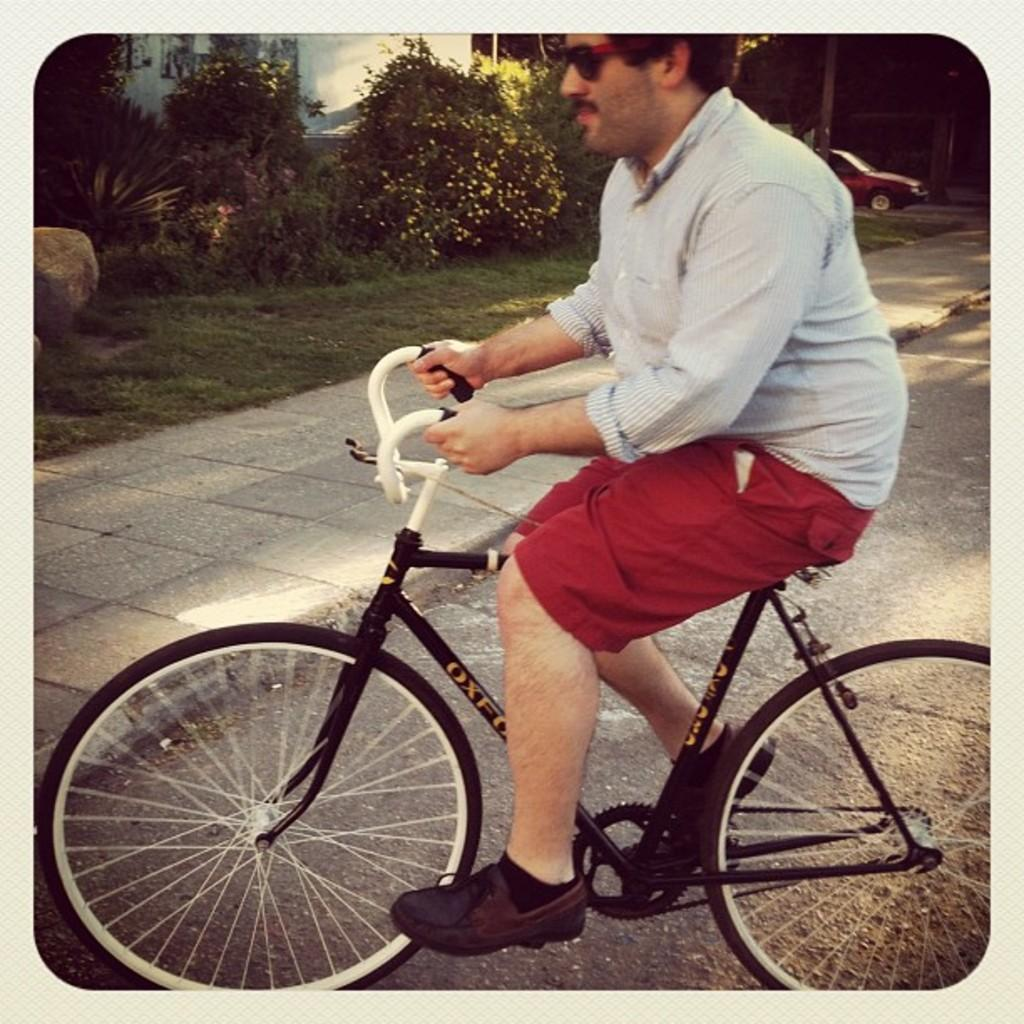Who is in the image? There is a man in the image. What is the man doing in the image? The man is sitting on a bicycle and riding it on a road. What can be seen alongside the road in the image? There is a footpath alongside the road. What type of vegetation is present in the image? There is grass and a tree in the image. What else can be seen in the background of the image? There is a car visible in the background of the image. What event is the man attending in the image? There is no indication of an event in the image; the man is simply riding a bicycle on a road. How does the man control his emotions while riding the bicycle in the image? The image does not provide any information about the man's emotions or how he controls them. 